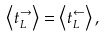<formula> <loc_0><loc_0><loc_500><loc_500>\left < t _ { L } ^ { \rightarrow } \right > = \left < t _ { L } ^ { \leftarrow } \right > ,</formula> 